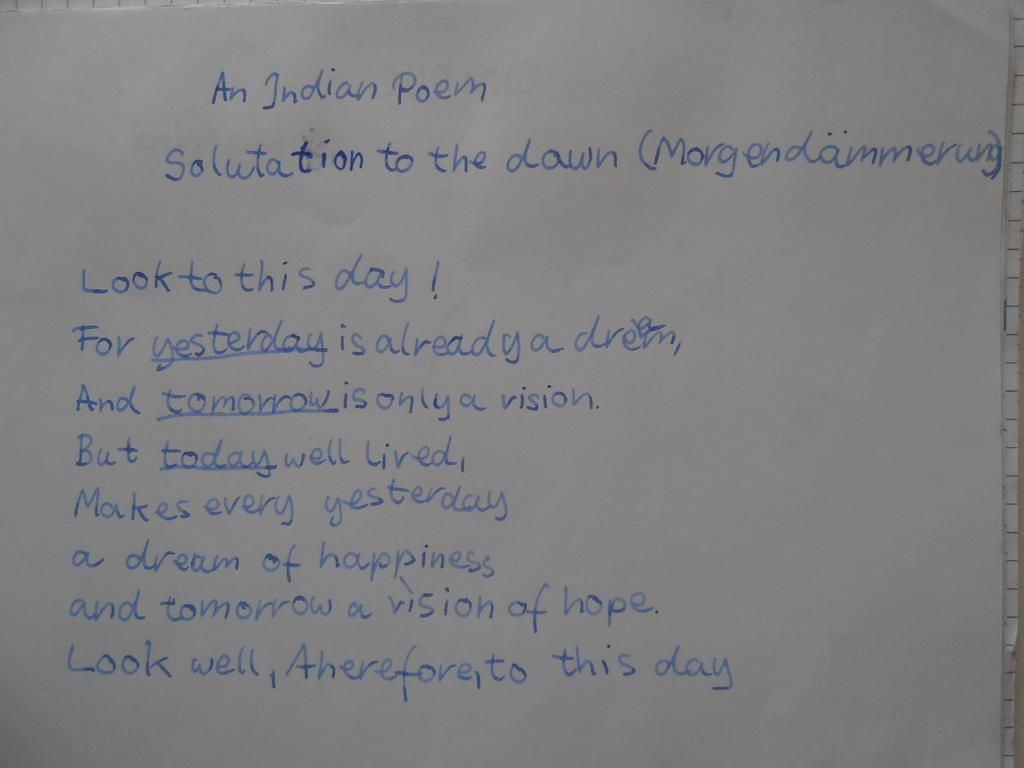<image>
Relay a brief, clear account of the picture shown. An Indian poem that is titled "Salutation To The Down". 